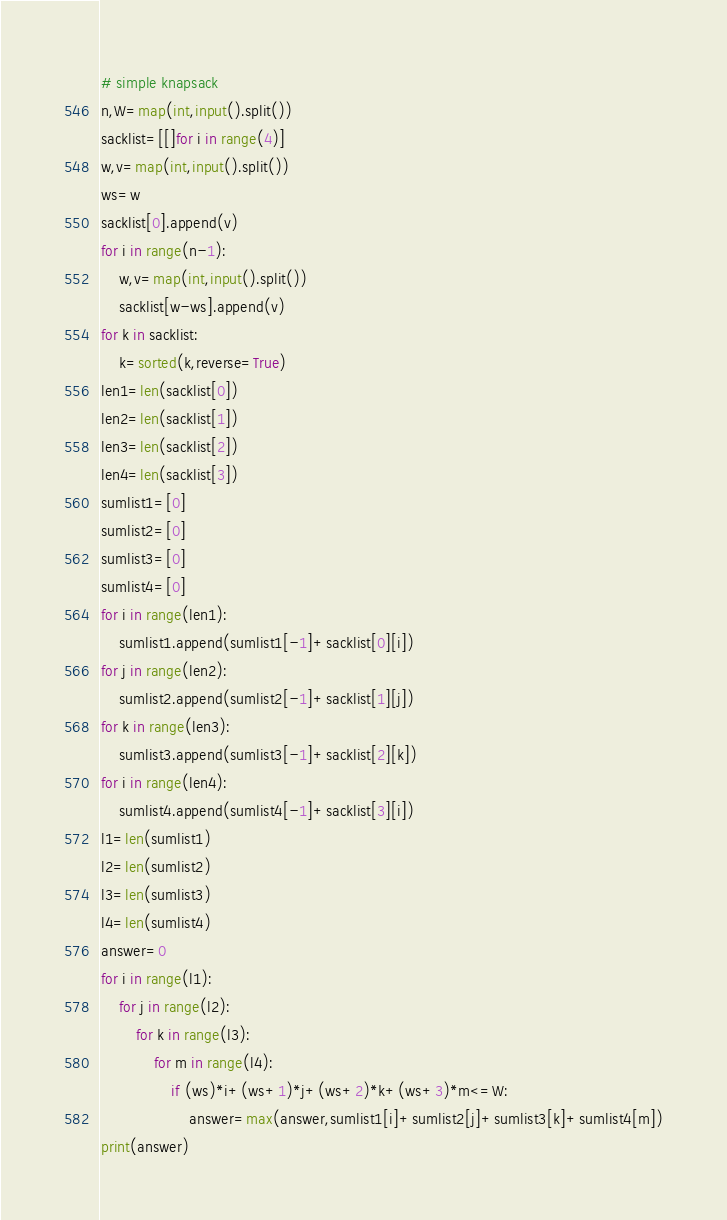Convert code to text. <code><loc_0><loc_0><loc_500><loc_500><_Python_># simple knapsack
n,W=map(int,input().split())
sacklist=[[]for i in range(4)]
w,v=map(int,input().split())
ws=w
sacklist[0].append(v)
for i in range(n-1):
    w,v=map(int,input().split())
    sacklist[w-ws].append(v)
for k in sacklist:
    k=sorted(k,reverse=True)
len1=len(sacklist[0])
len2=len(sacklist[1])
len3=len(sacklist[2])
len4=len(sacklist[3])
sumlist1=[0]
sumlist2=[0]
sumlist3=[0]
sumlist4=[0]
for i in range(len1):
    sumlist1.append(sumlist1[-1]+sacklist[0][i])
for j in range(len2):
    sumlist2.append(sumlist2[-1]+sacklist[1][j])
for k in range(len3):
    sumlist3.append(sumlist3[-1]+sacklist[2][k])
for i in range(len4):
    sumlist4.append(sumlist4[-1]+sacklist[3][i])
l1=len(sumlist1)
l2=len(sumlist2)
l3=len(sumlist3)
l4=len(sumlist4)
answer=0
for i in range(l1):
    for j in range(l2):
        for k in range(l3):
            for m in range(l4):
                if (ws)*i+(ws+1)*j+(ws+2)*k+(ws+3)*m<=W:
                    answer=max(answer,sumlist1[i]+sumlist2[j]+sumlist3[k]+sumlist4[m])
print(answer)
</code> 